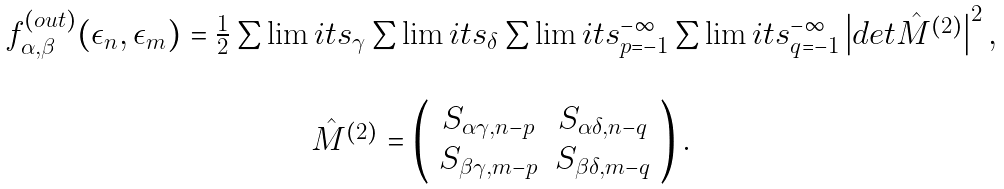Convert formula to latex. <formula><loc_0><loc_0><loc_500><loc_500>\begin{array} { c } f ^ { ( o u t ) } _ { \alpha , \beta } ( \epsilon _ { n } , \epsilon _ { m } ) = \frac { 1 } { 2 } \sum \lim i t s _ { \gamma } \sum \lim i t s _ { \delta } \sum \lim i t s _ { p = - 1 } ^ { - \infty } \sum \lim i t s _ { q = - 1 } ^ { - \infty } \left | d e t \hat { M } ^ { ( 2 ) } \right | ^ { 2 } , \\ \ \\ \hat { M } ^ { ( 2 ) } = \left ( \begin{array} { c c } S _ { \alpha \gamma , n - p } & S _ { \alpha \delta , n - q } \\ S _ { \beta \gamma , m - p } & S _ { \beta \delta , m - q } \end{array} \right ) . \end{array}</formula> 